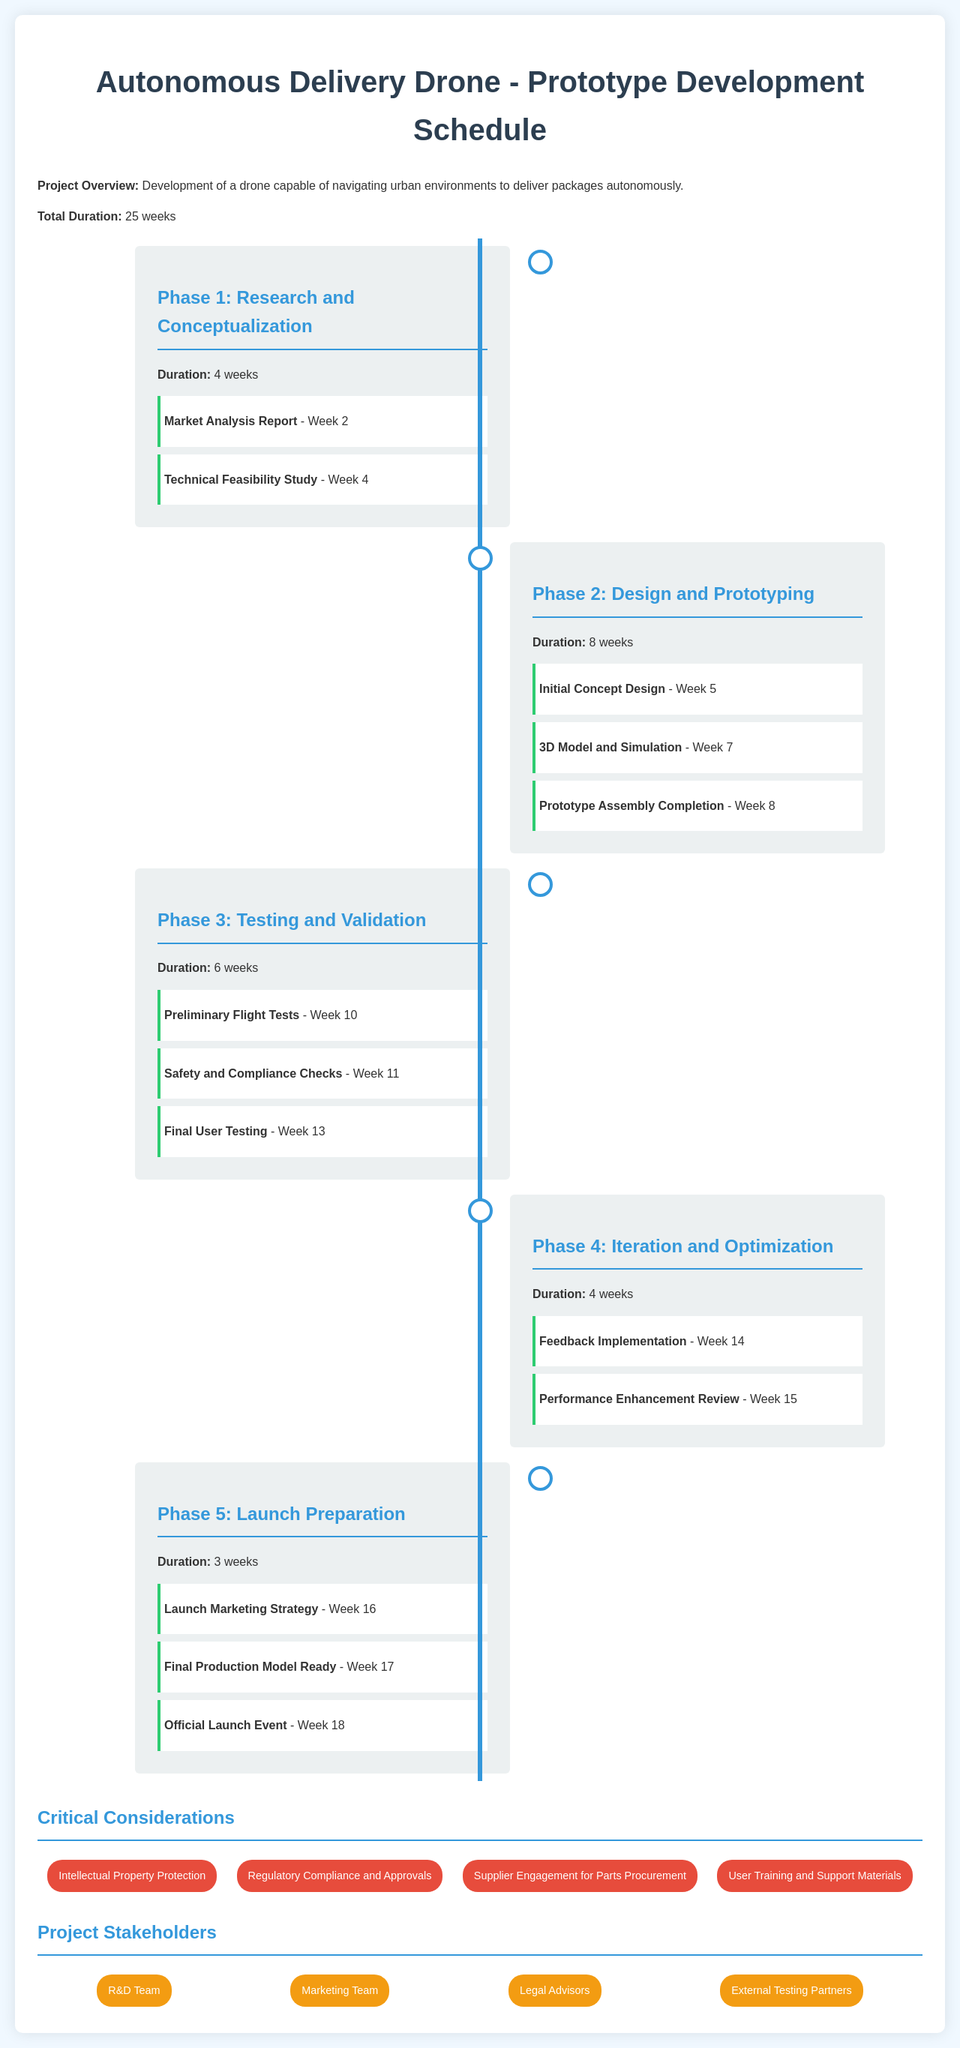What is the total duration of the project? The total duration of the project is specified in the document, which is 25 weeks.
Answer: 25 weeks What is the first milestone in Phase 1? The first milestone listed in Phase 1 is the "Market Analysis Report" which is due in Week 2.
Answer: Market Analysis Report Which phase has the longest duration? By comparing the durations of all phases, Phase 2 has the longest duration of 8 weeks.
Answer: 8 weeks What week is the "Final User Testing" scheduled? The document states that the "Final User Testing" is scheduled for Week 13 during Phase 3.
Answer: Week 13 Which team is responsible for launch marketing strategy? The project stakeholders include a Marketing Team, who would be responsible for the launch marketing strategy.
Answer: Marketing Team How many critical considerations are listed? There are four critical considerations mentioned in the document.
Answer: 4 What is the last event in the development schedule? The last event scheduled in the document is the "Official Launch Event" which occurs in Week 18.
Answer: Official Launch Event What milestone is scheduled in Week 15? The milestone scheduled in Week 15 is the "Performance Enhancement Review".
Answer: Performance Enhancement Review 